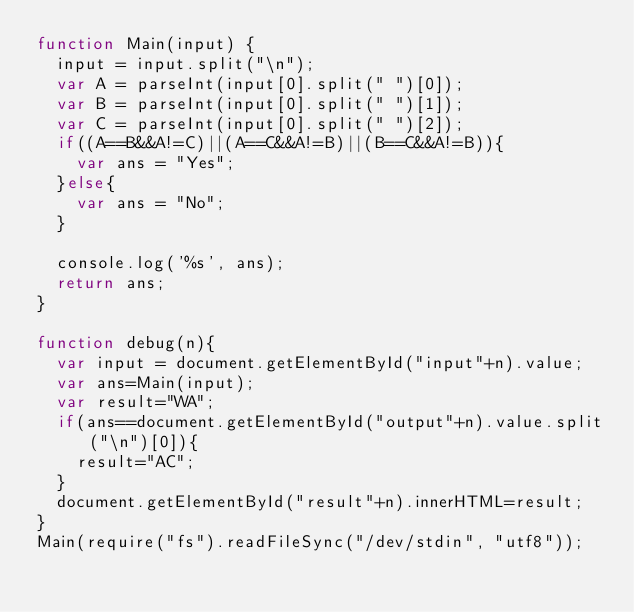<code> <loc_0><loc_0><loc_500><loc_500><_JavaScript_>function Main(input) {
  input = input.split("\n");
  var A = parseInt(input[0].split(" ")[0]);
  var B = parseInt(input[0].split(" ")[1]);
  var C = parseInt(input[0].split(" ")[2]);
  if((A==B&&A!=C)||(A==C&&A!=B)||(B==C&&A!=B)){
    var ans = "Yes";
  }else{
    var ans = "No";
  }

  console.log('%s', ans);
  return ans;
}

function debug(n){
  var input = document.getElementById("input"+n).value;
  var ans=Main(input);
  var result="WA";
  if(ans==document.getElementById("output"+n).value.split("\n")[0]){
    result="AC";
  }
  document.getElementById("result"+n).innerHTML=result;
}
Main(require("fs").readFileSync("/dev/stdin", "utf8"));</code> 